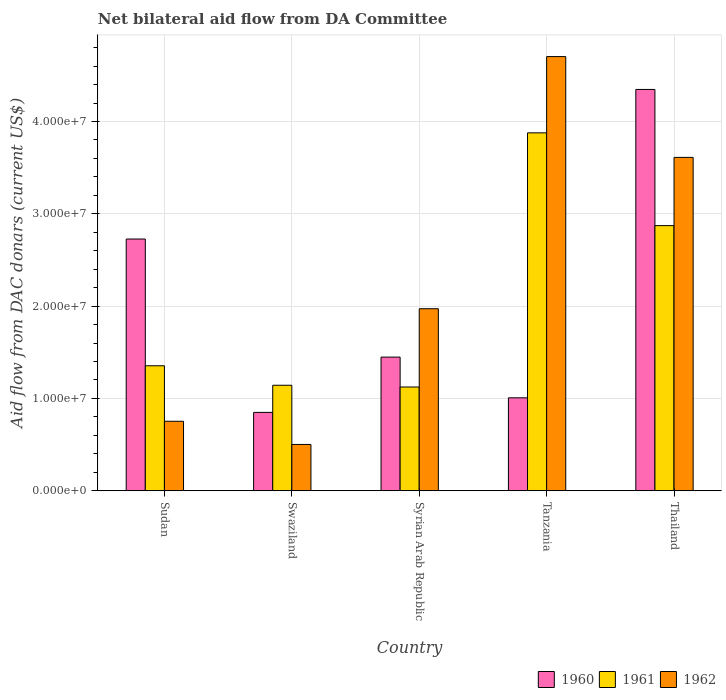How many groups of bars are there?
Your answer should be very brief. 5. How many bars are there on the 3rd tick from the right?
Ensure brevity in your answer.  3. What is the label of the 1st group of bars from the left?
Make the answer very short. Sudan. In how many cases, is the number of bars for a given country not equal to the number of legend labels?
Your response must be concise. 0. What is the aid flow in in 1960 in Syrian Arab Republic?
Give a very brief answer. 1.45e+07. Across all countries, what is the maximum aid flow in in 1960?
Give a very brief answer. 4.35e+07. Across all countries, what is the minimum aid flow in in 1961?
Ensure brevity in your answer.  1.12e+07. In which country was the aid flow in in 1961 maximum?
Provide a short and direct response. Tanzania. In which country was the aid flow in in 1960 minimum?
Make the answer very short. Swaziland. What is the total aid flow in in 1961 in the graph?
Keep it short and to the point. 1.04e+08. What is the difference between the aid flow in in 1960 in Swaziland and that in Thailand?
Keep it short and to the point. -3.50e+07. What is the difference between the aid flow in in 1960 in Tanzania and the aid flow in in 1962 in Swaziland?
Provide a succinct answer. 5.05e+06. What is the average aid flow in in 1961 per country?
Make the answer very short. 2.07e+07. What is the difference between the aid flow in of/in 1961 and aid flow in of/in 1962 in Swaziland?
Ensure brevity in your answer.  6.41e+06. What is the ratio of the aid flow in in 1960 in Sudan to that in Syrian Arab Republic?
Ensure brevity in your answer.  1.88. What is the difference between the highest and the second highest aid flow in in 1961?
Offer a very short reply. 1.00e+07. What is the difference between the highest and the lowest aid flow in in 1960?
Offer a very short reply. 3.50e+07. In how many countries, is the aid flow in in 1960 greater than the average aid flow in in 1960 taken over all countries?
Make the answer very short. 2. Is the sum of the aid flow in in 1962 in Sudan and Tanzania greater than the maximum aid flow in in 1960 across all countries?
Offer a terse response. Yes. Is it the case that in every country, the sum of the aid flow in in 1962 and aid flow in in 1960 is greater than the aid flow in in 1961?
Make the answer very short. Yes. How many bars are there?
Your answer should be compact. 15. How many countries are there in the graph?
Your response must be concise. 5. What is the difference between two consecutive major ticks on the Y-axis?
Make the answer very short. 1.00e+07. Are the values on the major ticks of Y-axis written in scientific E-notation?
Offer a very short reply. Yes. How are the legend labels stacked?
Offer a very short reply. Horizontal. What is the title of the graph?
Your answer should be compact. Net bilateral aid flow from DA Committee. Does "1989" appear as one of the legend labels in the graph?
Keep it short and to the point. No. What is the label or title of the X-axis?
Ensure brevity in your answer.  Country. What is the label or title of the Y-axis?
Make the answer very short. Aid flow from DAC donars (current US$). What is the Aid flow from DAC donars (current US$) of 1960 in Sudan?
Offer a terse response. 2.73e+07. What is the Aid flow from DAC donars (current US$) in 1961 in Sudan?
Give a very brief answer. 1.35e+07. What is the Aid flow from DAC donars (current US$) in 1962 in Sudan?
Offer a very short reply. 7.53e+06. What is the Aid flow from DAC donars (current US$) in 1960 in Swaziland?
Provide a succinct answer. 8.49e+06. What is the Aid flow from DAC donars (current US$) in 1961 in Swaziland?
Your answer should be very brief. 1.14e+07. What is the Aid flow from DAC donars (current US$) in 1962 in Swaziland?
Your response must be concise. 5.02e+06. What is the Aid flow from DAC donars (current US$) in 1960 in Syrian Arab Republic?
Your answer should be very brief. 1.45e+07. What is the Aid flow from DAC donars (current US$) of 1961 in Syrian Arab Republic?
Make the answer very short. 1.12e+07. What is the Aid flow from DAC donars (current US$) of 1962 in Syrian Arab Republic?
Ensure brevity in your answer.  1.97e+07. What is the Aid flow from DAC donars (current US$) in 1960 in Tanzania?
Offer a terse response. 1.01e+07. What is the Aid flow from DAC donars (current US$) in 1961 in Tanzania?
Keep it short and to the point. 3.88e+07. What is the Aid flow from DAC donars (current US$) of 1962 in Tanzania?
Give a very brief answer. 4.70e+07. What is the Aid flow from DAC donars (current US$) in 1960 in Thailand?
Keep it short and to the point. 4.35e+07. What is the Aid flow from DAC donars (current US$) of 1961 in Thailand?
Your response must be concise. 2.87e+07. What is the Aid flow from DAC donars (current US$) in 1962 in Thailand?
Your answer should be compact. 3.61e+07. Across all countries, what is the maximum Aid flow from DAC donars (current US$) of 1960?
Your answer should be compact. 4.35e+07. Across all countries, what is the maximum Aid flow from DAC donars (current US$) of 1961?
Provide a short and direct response. 3.88e+07. Across all countries, what is the maximum Aid flow from DAC donars (current US$) in 1962?
Provide a short and direct response. 4.70e+07. Across all countries, what is the minimum Aid flow from DAC donars (current US$) in 1960?
Make the answer very short. 8.49e+06. Across all countries, what is the minimum Aid flow from DAC donars (current US$) of 1961?
Your answer should be very brief. 1.12e+07. Across all countries, what is the minimum Aid flow from DAC donars (current US$) in 1962?
Ensure brevity in your answer.  5.02e+06. What is the total Aid flow from DAC donars (current US$) in 1960 in the graph?
Make the answer very short. 1.04e+08. What is the total Aid flow from DAC donars (current US$) of 1961 in the graph?
Your answer should be compact. 1.04e+08. What is the total Aid flow from DAC donars (current US$) of 1962 in the graph?
Ensure brevity in your answer.  1.15e+08. What is the difference between the Aid flow from DAC donars (current US$) of 1960 in Sudan and that in Swaziland?
Keep it short and to the point. 1.88e+07. What is the difference between the Aid flow from DAC donars (current US$) in 1961 in Sudan and that in Swaziland?
Provide a succinct answer. 2.11e+06. What is the difference between the Aid flow from DAC donars (current US$) of 1962 in Sudan and that in Swaziland?
Your answer should be very brief. 2.51e+06. What is the difference between the Aid flow from DAC donars (current US$) in 1960 in Sudan and that in Syrian Arab Republic?
Provide a succinct answer. 1.28e+07. What is the difference between the Aid flow from DAC donars (current US$) of 1961 in Sudan and that in Syrian Arab Republic?
Ensure brevity in your answer.  2.30e+06. What is the difference between the Aid flow from DAC donars (current US$) of 1962 in Sudan and that in Syrian Arab Republic?
Your answer should be compact. -1.22e+07. What is the difference between the Aid flow from DAC donars (current US$) of 1960 in Sudan and that in Tanzania?
Your response must be concise. 1.72e+07. What is the difference between the Aid flow from DAC donars (current US$) in 1961 in Sudan and that in Tanzania?
Ensure brevity in your answer.  -2.52e+07. What is the difference between the Aid flow from DAC donars (current US$) in 1962 in Sudan and that in Tanzania?
Give a very brief answer. -3.95e+07. What is the difference between the Aid flow from DAC donars (current US$) in 1960 in Sudan and that in Thailand?
Your answer should be very brief. -1.62e+07. What is the difference between the Aid flow from DAC donars (current US$) in 1961 in Sudan and that in Thailand?
Offer a terse response. -1.52e+07. What is the difference between the Aid flow from DAC donars (current US$) of 1962 in Sudan and that in Thailand?
Offer a very short reply. -2.86e+07. What is the difference between the Aid flow from DAC donars (current US$) of 1960 in Swaziland and that in Syrian Arab Republic?
Make the answer very short. -5.99e+06. What is the difference between the Aid flow from DAC donars (current US$) in 1962 in Swaziland and that in Syrian Arab Republic?
Provide a short and direct response. -1.47e+07. What is the difference between the Aid flow from DAC donars (current US$) of 1960 in Swaziland and that in Tanzania?
Provide a short and direct response. -1.58e+06. What is the difference between the Aid flow from DAC donars (current US$) in 1961 in Swaziland and that in Tanzania?
Provide a short and direct response. -2.73e+07. What is the difference between the Aid flow from DAC donars (current US$) in 1962 in Swaziland and that in Tanzania?
Provide a succinct answer. -4.20e+07. What is the difference between the Aid flow from DAC donars (current US$) of 1960 in Swaziland and that in Thailand?
Offer a very short reply. -3.50e+07. What is the difference between the Aid flow from DAC donars (current US$) in 1961 in Swaziland and that in Thailand?
Provide a succinct answer. -1.73e+07. What is the difference between the Aid flow from DAC donars (current US$) of 1962 in Swaziland and that in Thailand?
Keep it short and to the point. -3.11e+07. What is the difference between the Aid flow from DAC donars (current US$) of 1960 in Syrian Arab Republic and that in Tanzania?
Your response must be concise. 4.41e+06. What is the difference between the Aid flow from DAC donars (current US$) of 1961 in Syrian Arab Republic and that in Tanzania?
Your answer should be very brief. -2.75e+07. What is the difference between the Aid flow from DAC donars (current US$) of 1962 in Syrian Arab Republic and that in Tanzania?
Your response must be concise. -2.73e+07. What is the difference between the Aid flow from DAC donars (current US$) in 1960 in Syrian Arab Republic and that in Thailand?
Offer a very short reply. -2.90e+07. What is the difference between the Aid flow from DAC donars (current US$) in 1961 in Syrian Arab Republic and that in Thailand?
Offer a very short reply. -1.75e+07. What is the difference between the Aid flow from DAC donars (current US$) in 1962 in Syrian Arab Republic and that in Thailand?
Your response must be concise. -1.64e+07. What is the difference between the Aid flow from DAC donars (current US$) in 1960 in Tanzania and that in Thailand?
Your response must be concise. -3.34e+07. What is the difference between the Aid flow from DAC donars (current US$) in 1961 in Tanzania and that in Thailand?
Ensure brevity in your answer.  1.00e+07. What is the difference between the Aid flow from DAC donars (current US$) in 1962 in Tanzania and that in Thailand?
Provide a short and direct response. 1.09e+07. What is the difference between the Aid flow from DAC donars (current US$) in 1960 in Sudan and the Aid flow from DAC donars (current US$) in 1961 in Swaziland?
Your response must be concise. 1.58e+07. What is the difference between the Aid flow from DAC donars (current US$) in 1960 in Sudan and the Aid flow from DAC donars (current US$) in 1962 in Swaziland?
Provide a short and direct response. 2.22e+07. What is the difference between the Aid flow from DAC donars (current US$) of 1961 in Sudan and the Aid flow from DAC donars (current US$) of 1962 in Swaziland?
Your response must be concise. 8.52e+06. What is the difference between the Aid flow from DAC donars (current US$) of 1960 in Sudan and the Aid flow from DAC donars (current US$) of 1961 in Syrian Arab Republic?
Keep it short and to the point. 1.60e+07. What is the difference between the Aid flow from DAC donars (current US$) of 1960 in Sudan and the Aid flow from DAC donars (current US$) of 1962 in Syrian Arab Republic?
Your response must be concise. 7.55e+06. What is the difference between the Aid flow from DAC donars (current US$) in 1961 in Sudan and the Aid flow from DAC donars (current US$) in 1962 in Syrian Arab Republic?
Provide a succinct answer. -6.18e+06. What is the difference between the Aid flow from DAC donars (current US$) in 1960 in Sudan and the Aid flow from DAC donars (current US$) in 1961 in Tanzania?
Your response must be concise. -1.15e+07. What is the difference between the Aid flow from DAC donars (current US$) in 1960 in Sudan and the Aid flow from DAC donars (current US$) in 1962 in Tanzania?
Offer a terse response. -1.98e+07. What is the difference between the Aid flow from DAC donars (current US$) in 1961 in Sudan and the Aid flow from DAC donars (current US$) in 1962 in Tanzania?
Give a very brief answer. -3.35e+07. What is the difference between the Aid flow from DAC donars (current US$) in 1960 in Sudan and the Aid flow from DAC donars (current US$) in 1961 in Thailand?
Your answer should be compact. -1.45e+06. What is the difference between the Aid flow from DAC donars (current US$) of 1960 in Sudan and the Aid flow from DAC donars (current US$) of 1962 in Thailand?
Keep it short and to the point. -8.84e+06. What is the difference between the Aid flow from DAC donars (current US$) of 1961 in Sudan and the Aid flow from DAC donars (current US$) of 1962 in Thailand?
Offer a terse response. -2.26e+07. What is the difference between the Aid flow from DAC donars (current US$) of 1960 in Swaziland and the Aid flow from DAC donars (current US$) of 1961 in Syrian Arab Republic?
Your answer should be compact. -2.75e+06. What is the difference between the Aid flow from DAC donars (current US$) of 1960 in Swaziland and the Aid flow from DAC donars (current US$) of 1962 in Syrian Arab Republic?
Provide a succinct answer. -1.12e+07. What is the difference between the Aid flow from DAC donars (current US$) in 1961 in Swaziland and the Aid flow from DAC donars (current US$) in 1962 in Syrian Arab Republic?
Provide a short and direct response. -8.29e+06. What is the difference between the Aid flow from DAC donars (current US$) of 1960 in Swaziland and the Aid flow from DAC donars (current US$) of 1961 in Tanzania?
Your answer should be very brief. -3.03e+07. What is the difference between the Aid flow from DAC donars (current US$) in 1960 in Swaziland and the Aid flow from DAC donars (current US$) in 1962 in Tanzania?
Offer a terse response. -3.85e+07. What is the difference between the Aid flow from DAC donars (current US$) of 1961 in Swaziland and the Aid flow from DAC donars (current US$) of 1962 in Tanzania?
Your answer should be compact. -3.56e+07. What is the difference between the Aid flow from DAC donars (current US$) in 1960 in Swaziland and the Aid flow from DAC donars (current US$) in 1961 in Thailand?
Keep it short and to the point. -2.02e+07. What is the difference between the Aid flow from DAC donars (current US$) of 1960 in Swaziland and the Aid flow from DAC donars (current US$) of 1962 in Thailand?
Your answer should be compact. -2.76e+07. What is the difference between the Aid flow from DAC donars (current US$) of 1961 in Swaziland and the Aid flow from DAC donars (current US$) of 1962 in Thailand?
Provide a short and direct response. -2.47e+07. What is the difference between the Aid flow from DAC donars (current US$) of 1960 in Syrian Arab Republic and the Aid flow from DAC donars (current US$) of 1961 in Tanzania?
Your answer should be compact. -2.43e+07. What is the difference between the Aid flow from DAC donars (current US$) of 1960 in Syrian Arab Republic and the Aid flow from DAC donars (current US$) of 1962 in Tanzania?
Offer a very short reply. -3.26e+07. What is the difference between the Aid flow from DAC donars (current US$) in 1961 in Syrian Arab Republic and the Aid flow from DAC donars (current US$) in 1962 in Tanzania?
Give a very brief answer. -3.58e+07. What is the difference between the Aid flow from DAC donars (current US$) of 1960 in Syrian Arab Republic and the Aid flow from DAC donars (current US$) of 1961 in Thailand?
Your answer should be compact. -1.42e+07. What is the difference between the Aid flow from DAC donars (current US$) of 1960 in Syrian Arab Republic and the Aid flow from DAC donars (current US$) of 1962 in Thailand?
Your answer should be very brief. -2.16e+07. What is the difference between the Aid flow from DAC donars (current US$) of 1961 in Syrian Arab Republic and the Aid flow from DAC donars (current US$) of 1962 in Thailand?
Provide a short and direct response. -2.49e+07. What is the difference between the Aid flow from DAC donars (current US$) in 1960 in Tanzania and the Aid flow from DAC donars (current US$) in 1961 in Thailand?
Provide a succinct answer. -1.86e+07. What is the difference between the Aid flow from DAC donars (current US$) in 1960 in Tanzania and the Aid flow from DAC donars (current US$) in 1962 in Thailand?
Provide a succinct answer. -2.60e+07. What is the difference between the Aid flow from DAC donars (current US$) in 1961 in Tanzania and the Aid flow from DAC donars (current US$) in 1962 in Thailand?
Make the answer very short. 2.66e+06. What is the average Aid flow from DAC donars (current US$) in 1960 per country?
Your response must be concise. 2.08e+07. What is the average Aid flow from DAC donars (current US$) in 1961 per country?
Provide a short and direct response. 2.07e+07. What is the average Aid flow from DAC donars (current US$) in 1962 per country?
Offer a very short reply. 2.31e+07. What is the difference between the Aid flow from DAC donars (current US$) of 1960 and Aid flow from DAC donars (current US$) of 1961 in Sudan?
Your answer should be compact. 1.37e+07. What is the difference between the Aid flow from DAC donars (current US$) of 1960 and Aid flow from DAC donars (current US$) of 1962 in Sudan?
Your answer should be compact. 1.97e+07. What is the difference between the Aid flow from DAC donars (current US$) of 1961 and Aid flow from DAC donars (current US$) of 1962 in Sudan?
Your answer should be compact. 6.01e+06. What is the difference between the Aid flow from DAC donars (current US$) of 1960 and Aid flow from DAC donars (current US$) of 1961 in Swaziland?
Give a very brief answer. -2.94e+06. What is the difference between the Aid flow from DAC donars (current US$) in 1960 and Aid flow from DAC donars (current US$) in 1962 in Swaziland?
Provide a succinct answer. 3.47e+06. What is the difference between the Aid flow from DAC donars (current US$) in 1961 and Aid flow from DAC donars (current US$) in 1962 in Swaziland?
Ensure brevity in your answer.  6.41e+06. What is the difference between the Aid flow from DAC donars (current US$) in 1960 and Aid flow from DAC donars (current US$) in 1961 in Syrian Arab Republic?
Your response must be concise. 3.24e+06. What is the difference between the Aid flow from DAC donars (current US$) of 1960 and Aid flow from DAC donars (current US$) of 1962 in Syrian Arab Republic?
Provide a short and direct response. -5.24e+06. What is the difference between the Aid flow from DAC donars (current US$) of 1961 and Aid flow from DAC donars (current US$) of 1962 in Syrian Arab Republic?
Your response must be concise. -8.48e+06. What is the difference between the Aid flow from DAC donars (current US$) of 1960 and Aid flow from DAC donars (current US$) of 1961 in Tanzania?
Provide a succinct answer. -2.87e+07. What is the difference between the Aid flow from DAC donars (current US$) of 1960 and Aid flow from DAC donars (current US$) of 1962 in Tanzania?
Offer a terse response. -3.70e+07. What is the difference between the Aid flow from DAC donars (current US$) in 1961 and Aid flow from DAC donars (current US$) in 1962 in Tanzania?
Keep it short and to the point. -8.26e+06. What is the difference between the Aid flow from DAC donars (current US$) in 1960 and Aid flow from DAC donars (current US$) in 1961 in Thailand?
Ensure brevity in your answer.  1.48e+07. What is the difference between the Aid flow from DAC donars (current US$) in 1960 and Aid flow from DAC donars (current US$) in 1962 in Thailand?
Ensure brevity in your answer.  7.36e+06. What is the difference between the Aid flow from DAC donars (current US$) of 1961 and Aid flow from DAC donars (current US$) of 1962 in Thailand?
Your answer should be compact. -7.39e+06. What is the ratio of the Aid flow from DAC donars (current US$) of 1960 in Sudan to that in Swaziland?
Offer a terse response. 3.21. What is the ratio of the Aid flow from DAC donars (current US$) in 1961 in Sudan to that in Swaziland?
Your answer should be very brief. 1.18. What is the ratio of the Aid flow from DAC donars (current US$) in 1960 in Sudan to that in Syrian Arab Republic?
Offer a very short reply. 1.88. What is the ratio of the Aid flow from DAC donars (current US$) in 1961 in Sudan to that in Syrian Arab Republic?
Provide a short and direct response. 1.2. What is the ratio of the Aid flow from DAC donars (current US$) of 1962 in Sudan to that in Syrian Arab Republic?
Your response must be concise. 0.38. What is the ratio of the Aid flow from DAC donars (current US$) of 1960 in Sudan to that in Tanzania?
Make the answer very short. 2.71. What is the ratio of the Aid flow from DAC donars (current US$) in 1961 in Sudan to that in Tanzania?
Your answer should be very brief. 0.35. What is the ratio of the Aid flow from DAC donars (current US$) in 1962 in Sudan to that in Tanzania?
Your answer should be very brief. 0.16. What is the ratio of the Aid flow from DAC donars (current US$) in 1960 in Sudan to that in Thailand?
Your response must be concise. 0.63. What is the ratio of the Aid flow from DAC donars (current US$) of 1961 in Sudan to that in Thailand?
Ensure brevity in your answer.  0.47. What is the ratio of the Aid flow from DAC donars (current US$) of 1962 in Sudan to that in Thailand?
Your response must be concise. 0.21. What is the ratio of the Aid flow from DAC donars (current US$) in 1960 in Swaziland to that in Syrian Arab Republic?
Your answer should be compact. 0.59. What is the ratio of the Aid flow from DAC donars (current US$) of 1961 in Swaziland to that in Syrian Arab Republic?
Provide a short and direct response. 1.02. What is the ratio of the Aid flow from DAC donars (current US$) of 1962 in Swaziland to that in Syrian Arab Republic?
Your answer should be very brief. 0.25. What is the ratio of the Aid flow from DAC donars (current US$) in 1960 in Swaziland to that in Tanzania?
Ensure brevity in your answer.  0.84. What is the ratio of the Aid flow from DAC donars (current US$) of 1961 in Swaziland to that in Tanzania?
Provide a short and direct response. 0.29. What is the ratio of the Aid flow from DAC donars (current US$) in 1962 in Swaziland to that in Tanzania?
Give a very brief answer. 0.11. What is the ratio of the Aid flow from DAC donars (current US$) in 1960 in Swaziland to that in Thailand?
Provide a short and direct response. 0.2. What is the ratio of the Aid flow from DAC donars (current US$) of 1961 in Swaziland to that in Thailand?
Your answer should be compact. 0.4. What is the ratio of the Aid flow from DAC donars (current US$) of 1962 in Swaziland to that in Thailand?
Ensure brevity in your answer.  0.14. What is the ratio of the Aid flow from DAC donars (current US$) of 1960 in Syrian Arab Republic to that in Tanzania?
Provide a short and direct response. 1.44. What is the ratio of the Aid flow from DAC donars (current US$) of 1961 in Syrian Arab Republic to that in Tanzania?
Your response must be concise. 0.29. What is the ratio of the Aid flow from DAC donars (current US$) of 1962 in Syrian Arab Republic to that in Tanzania?
Make the answer very short. 0.42. What is the ratio of the Aid flow from DAC donars (current US$) in 1960 in Syrian Arab Republic to that in Thailand?
Your answer should be compact. 0.33. What is the ratio of the Aid flow from DAC donars (current US$) of 1961 in Syrian Arab Republic to that in Thailand?
Your response must be concise. 0.39. What is the ratio of the Aid flow from DAC donars (current US$) in 1962 in Syrian Arab Republic to that in Thailand?
Offer a terse response. 0.55. What is the ratio of the Aid flow from DAC donars (current US$) of 1960 in Tanzania to that in Thailand?
Make the answer very short. 0.23. What is the ratio of the Aid flow from DAC donars (current US$) of 1961 in Tanzania to that in Thailand?
Ensure brevity in your answer.  1.35. What is the ratio of the Aid flow from DAC donars (current US$) in 1962 in Tanzania to that in Thailand?
Provide a short and direct response. 1.3. What is the difference between the highest and the second highest Aid flow from DAC donars (current US$) of 1960?
Give a very brief answer. 1.62e+07. What is the difference between the highest and the second highest Aid flow from DAC donars (current US$) of 1961?
Provide a succinct answer. 1.00e+07. What is the difference between the highest and the second highest Aid flow from DAC donars (current US$) of 1962?
Ensure brevity in your answer.  1.09e+07. What is the difference between the highest and the lowest Aid flow from DAC donars (current US$) of 1960?
Give a very brief answer. 3.50e+07. What is the difference between the highest and the lowest Aid flow from DAC donars (current US$) of 1961?
Provide a succinct answer. 2.75e+07. What is the difference between the highest and the lowest Aid flow from DAC donars (current US$) of 1962?
Keep it short and to the point. 4.20e+07. 